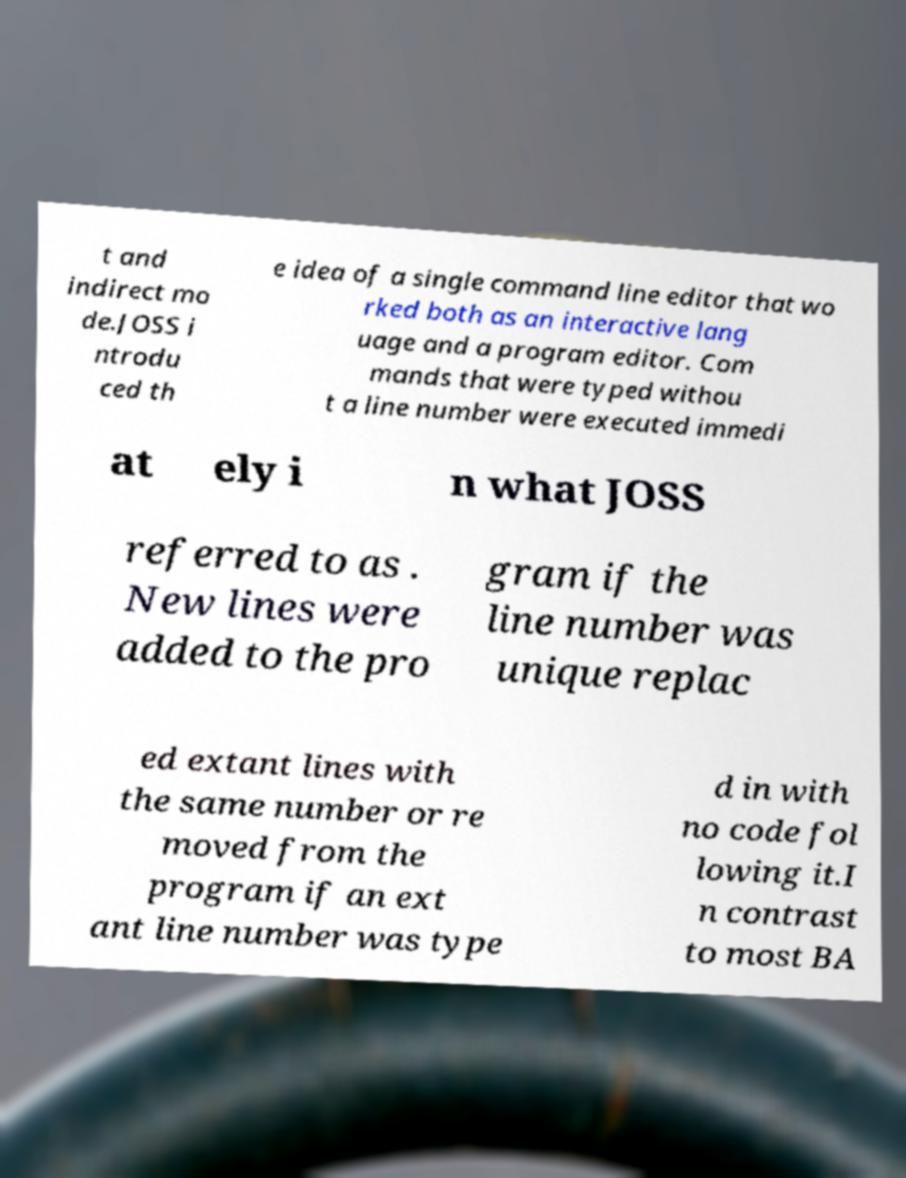I need the written content from this picture converted into text. Can you do that? t and indirect mo de.JOSS i ntrodu ced th e idea of a single command line editor that wo rked both as an interactive lang uage and a program editor. Com mands that were typed withou t a line number were executed immedi at ely i n what JOSS referred to as . New lines were added to the pro gram if the line number was unique replac ed extant lines with the same number or re moved from the program if an ext ant line number was type d in with no code fol lowing it.I n contrast to most BA 